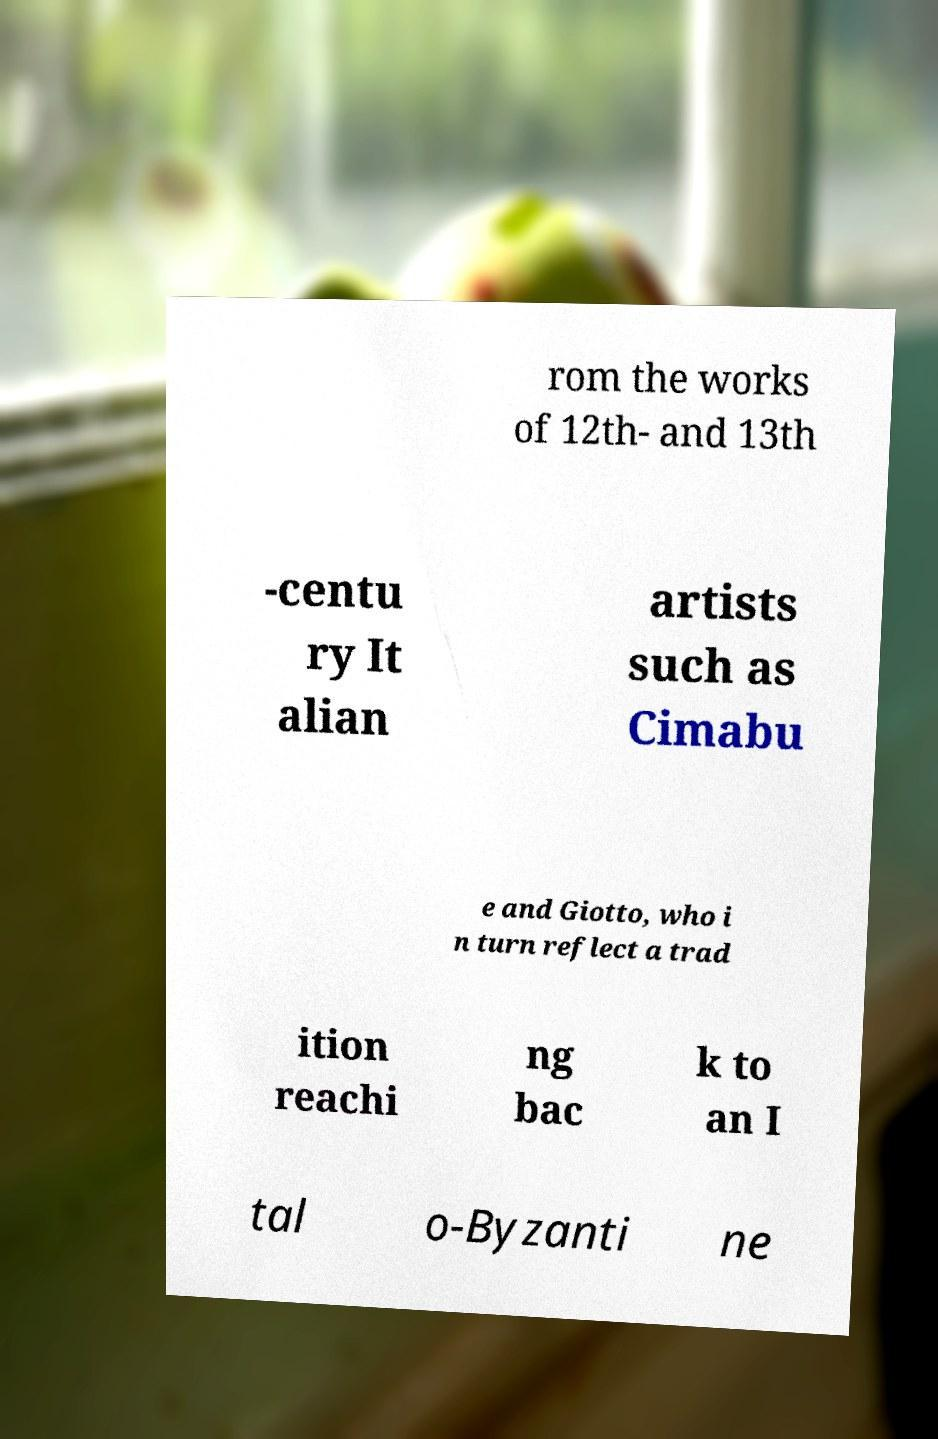There's text embedded in this image that I need extracted. Can you transcribe it verbatim? rom the works of 12th- and 13th -centu ry It alian artists such as Cimabu e and Giotto, who i n turn reflect a trad ition reachi ng bac k to an I tal o-Byzanti ne 